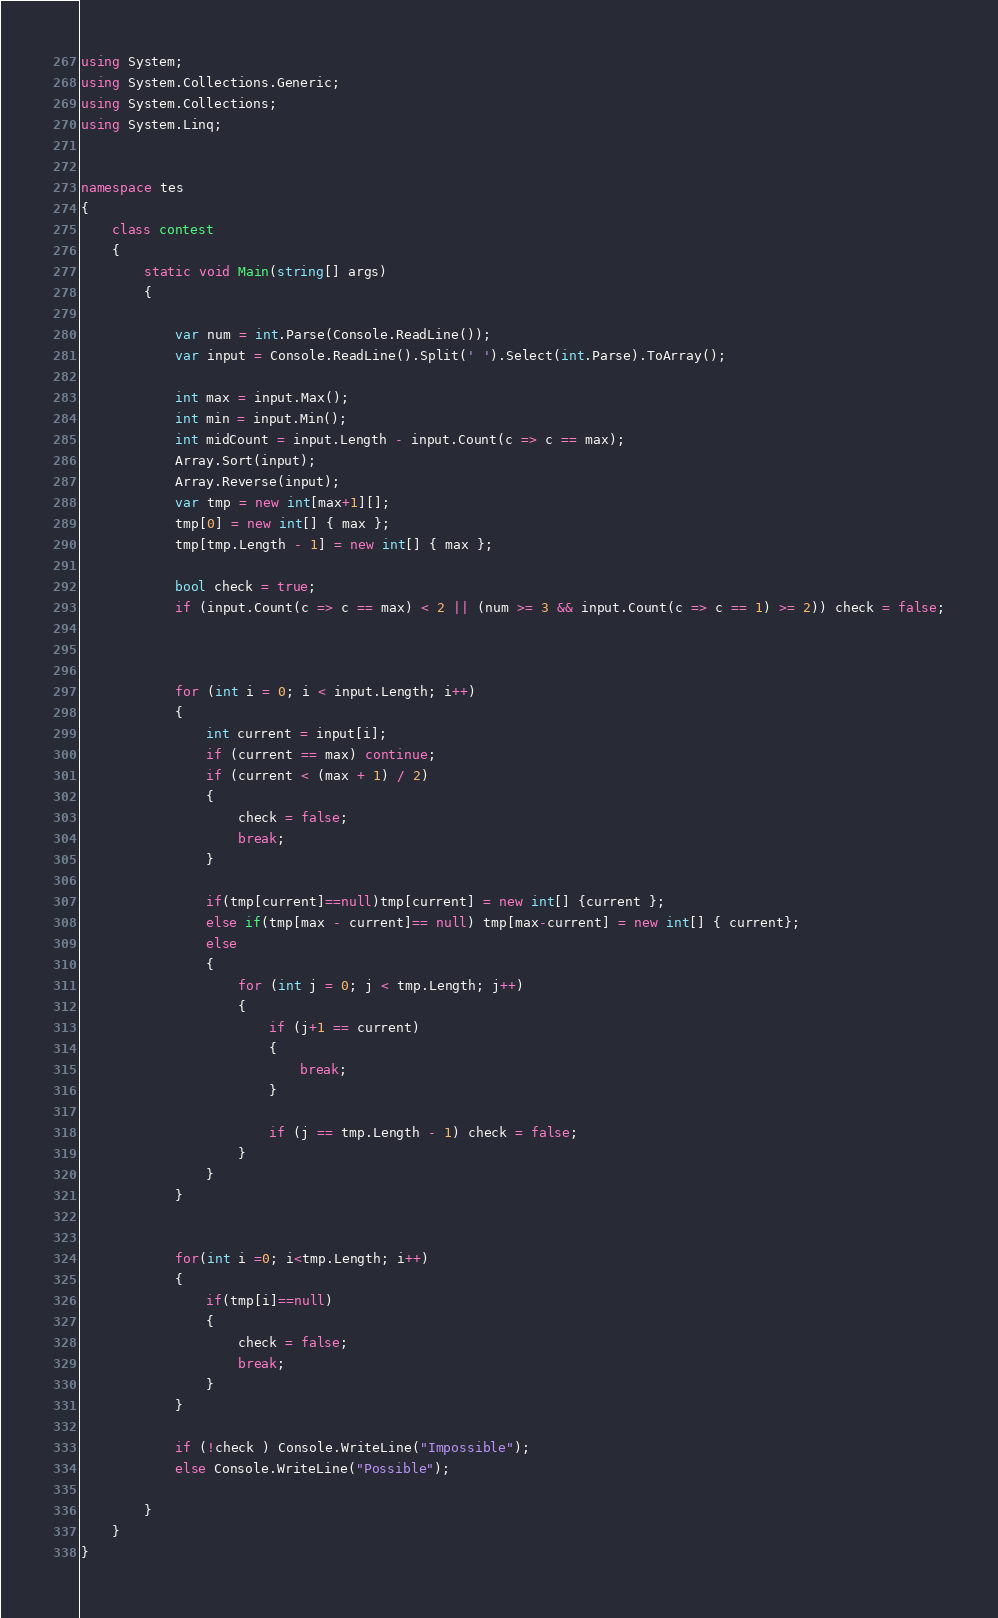Convert code to text. <code><loc_0><loc_0><loc_500><loc_500><_C#_>using System;
using System.Collections.Generic;
using System.Collections;
using System.Linq;


namespace tes
{
	class contest
	{
		static void Main(string[] args)
		{
			 
            var num = int.Parse(Console.ReadLine());
            var input = Console.ReadLine().Split(' ').Select(int.Parse).ToArray();

            int max = input.Max();
            int min = input.Min();
            int midCount = input.Length - input.Count(c => c == max);
            Array.Sort(input);
            Array.Reverse(input);
            var tmp = new int[max+1][];
            tmp[0] = new int[] { max };
            tmp[tmp.Length - 1] = new int[] { max };

            bool check = true;
            if (input.Count(c => c == max) < 2 || (num >= 3 && input.Count(c => c == 1) >= 2)) check = false;

           
            
            for (int i = 0; i < input.Length; i++)
            {
                int current = input[i];
                if (current == max) continue;
				if (current < (max + 1) / 2)
                {
                    check = false;
                    break;
                }
				
                if(tmp[current]==null)tmp[current] = new int[] {current };
                else if(tmp[max - current]== null) tmp[max-current] = new int[] { current};
                else
                {
                    for (int j = 0; j < tmp.Length; j++)
                    {
                        if (j+1 == current) 
                        {
                            break;
                        }

                        if (j == tmp.Length - 1) check = false;
                    }
                }
            }
            

            for(int i =0; i<tmp.Length; i++)
            {
                if(tmp[i]==null)
                {
                    check = false;
                    break;
                }
            }

            if (!check ) Console.WriteLine("Impossible");
            else Console.WriteLine("Possible");

		}				 
	}
}</code> 